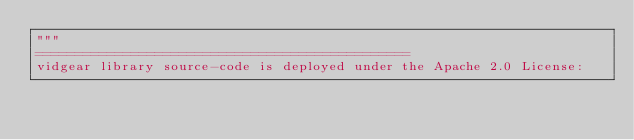<code> <loc_0><loc_0><loc_500><loc_500><_Python_>"""
===============================================
vidgear library source-code is deployed under the Apache 2.0 License:
</code> 